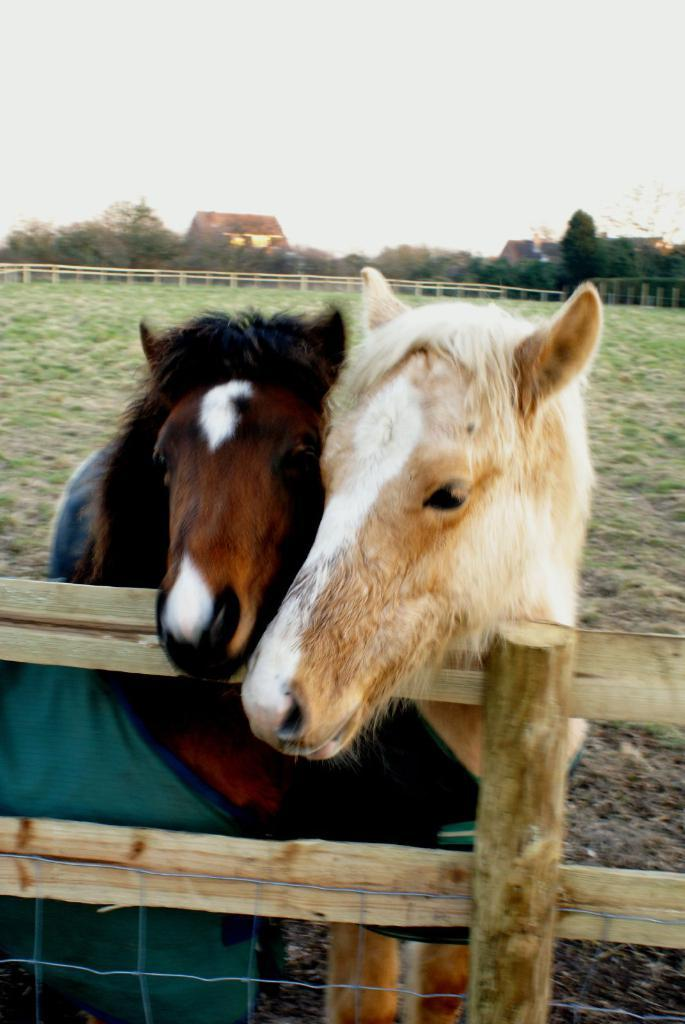How many horses are in the image? There are two horses in the image. What is near the horses in the image? The horses are near a wooden fence. What type of vegetation can be seen in the background of the image? There is grass visible in the background of the image. What type of structures can be seen in the background of the image? There are houses in the background of the image. What else can be seen in the background of the image? There are trees and the sky visible in the background of the image. What type of power source is visible in the image? There is no power source visible in the image; it features two horses near a wooden fence with a grassy background and houses, trees, and the sky in the distance. 